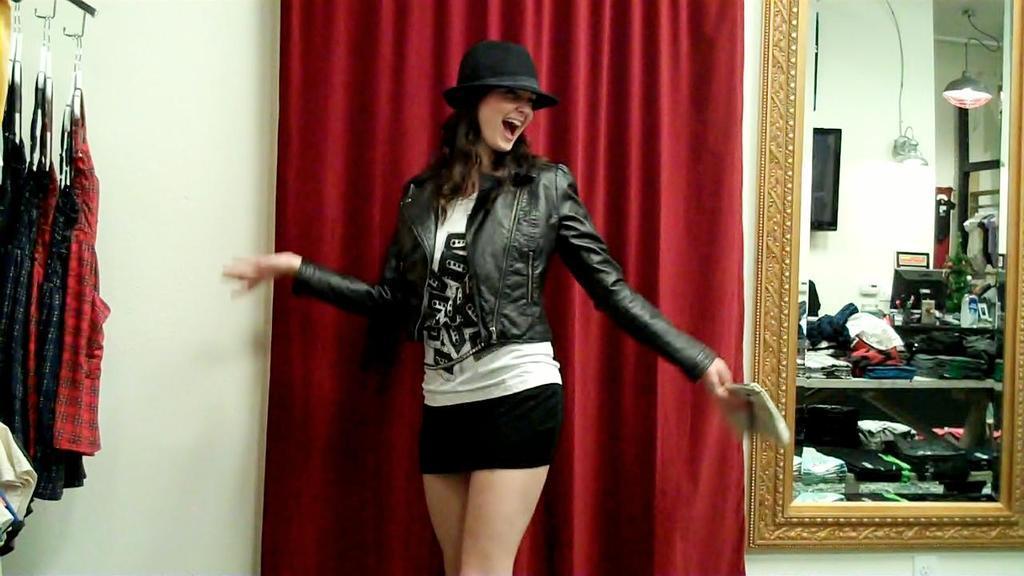Please provide a concise description of this image. In this picture I can see a woman in the middle, in the background there is the curtain, on the left side there are dresses, on the right side there is a mirror, on this mirror, there is a reflected image of some things and a light. 